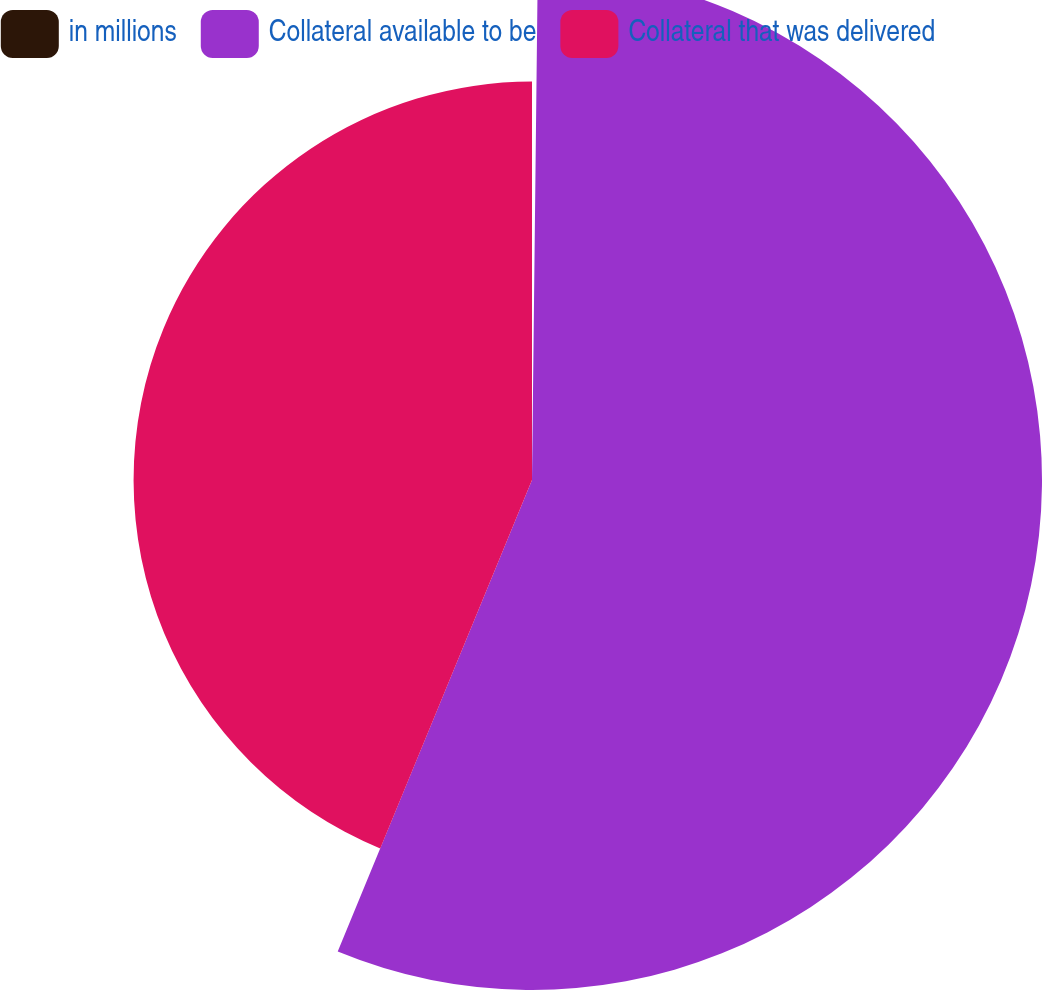<chart> <loc_0><loc_0><loc_500><loc_500><pie_chart><fcel>in millions<fcel>Collateral available to be<fcel>Collateral that was delivered<nl><fcel>0.18%<fcel>56.04%<fcel>43.78%<nl></chart> 